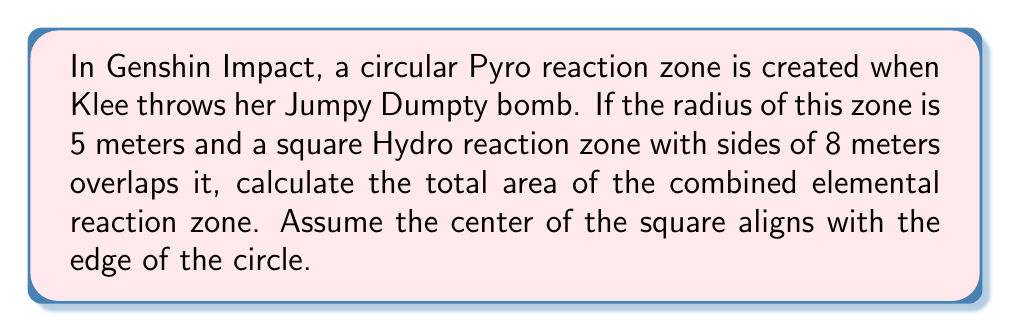Can you answer this question? Let's approach this step-by-step:

1) First, we need to calculate the area of the circular Pyro zone:
   $$A_{circle} = \pi r^2 = \pi (5^2) = 25\pi \approx 78.54 \text{ m}^2$$

2) Next, we calculate the area of the square Hydro zone:
   $$A_{square} = s^2 = 8^2 = 64 \text{ m}^2$$

3) Now, we need to find the area of overlap to avoid counting it twice. The overlapping region is a circular segment.

4) To find the area of the circular segment, we first need to calculate the central angle $\theta$ in radians:
   $$\cos(\theta/2) = 4/5$$
   $$\theta = 2 \arccos(4/5) \approx 1.2870 \text{ radians}$$

5) The area of the circular segment is:
   $$A_{segment} = r^2(\theta - \sin\theta)/2$$
   $$A_{segment} = 25(1.2870 - \sin(1.2870))/2 \approx 8.03 \text{ m}^2$$

6) The total area is the sum of the circle and square areas, minus the overlapping segment:
   $$A_{total} = A_{circle} + A_{square} - A_{segment}$$
   $$A_{total} = 78.54 + 64 - 8.03 = 134.51 \text{ m}^2$$

[asy]
unitsize(10mm);
fill(circle((0,0),5), red+opacity(0.3));
fill(shift(5,0)*square((-4,-4),8), blue+opacity(0.3));
draw(circle((0,0),5));
draw(shift(5,0)*square((-4,-4),8));
label("5m", (2.5,0), S);
label("8m", (5,4), E);
[/asy]
Answer: $134.51 \text{ m}^2$ 